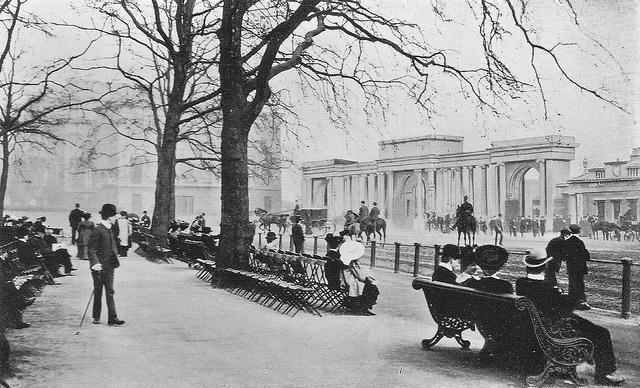How many people are there?
Give a very brief answer. 2. How many benches are in the picture?
Give a very brief answer. 2. 